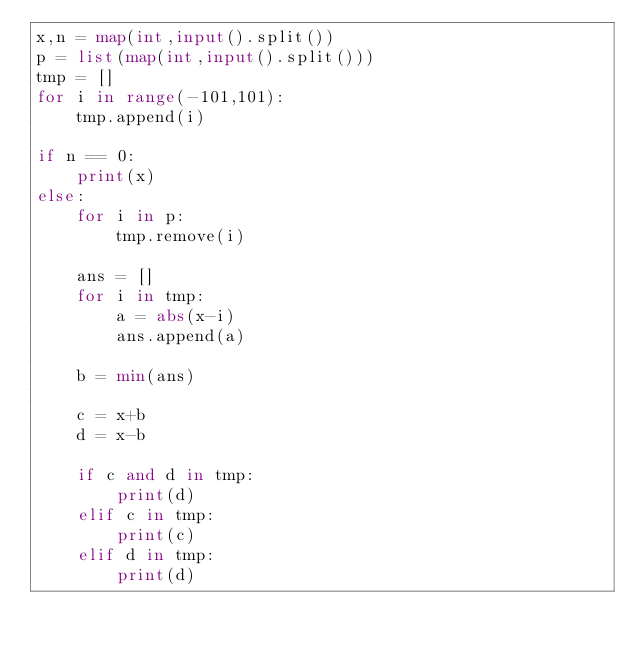<code> <loc_0><loc_0><loc_500><loc_500><_Python_>x,n = map(int,input().split())
p = list(map(int,input().split()))
tmp = []
for i in range(-101,101):
    tmp.append(i)

if n == 0:
    print(x)
else:
    for i in p:
        tmp.remove(i)
    
    ans = []
    for i in tmp:
        a = abs(x-i)
        ans.append(a)

    b = min(ans)
    
    c = x+b
    d = x-b

    if c and d in tmp:
        print(d)
    elif c in tmp:
        print(c)
    elif d in tmp:
        print(d)</code> 